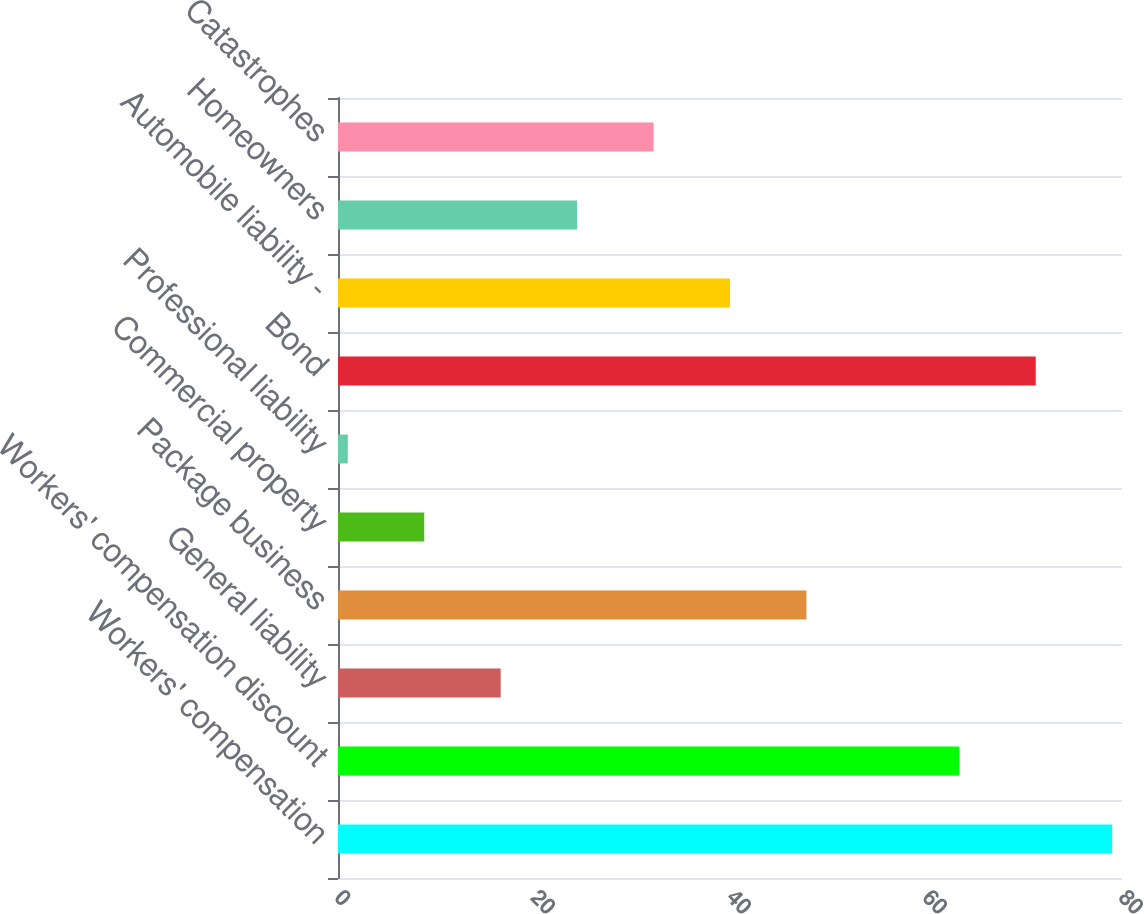Convert chart to OTSL. <chart><loc_0><loc_0><loc_500><loc_500><bar_chart><fcel>Workers' compensation<fcel>Workers' compensation discount<fcel>General liability<fcel>Package business<fcel>Commercial property<fcel>Professional liability<fcel>Bond<fcel>Automobile liability -<fcel>Homeowners<fcel>Catastrophes<nl><fcel>79<fcel>63.4<fcel>16.6<fcel>47.8<fcel>8.8<fcel>1<fcel>71.2<fcel>40<fcel>24.4<fcel>32.2<nl></chart> 